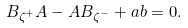Convert formula to latex. <formula><loc_0><loc_0><loc_500><loc_500>B _ { \zeta ^ { + } } A - A B _ { \zeta ^ { - } } + a b = 0 .</formula> 